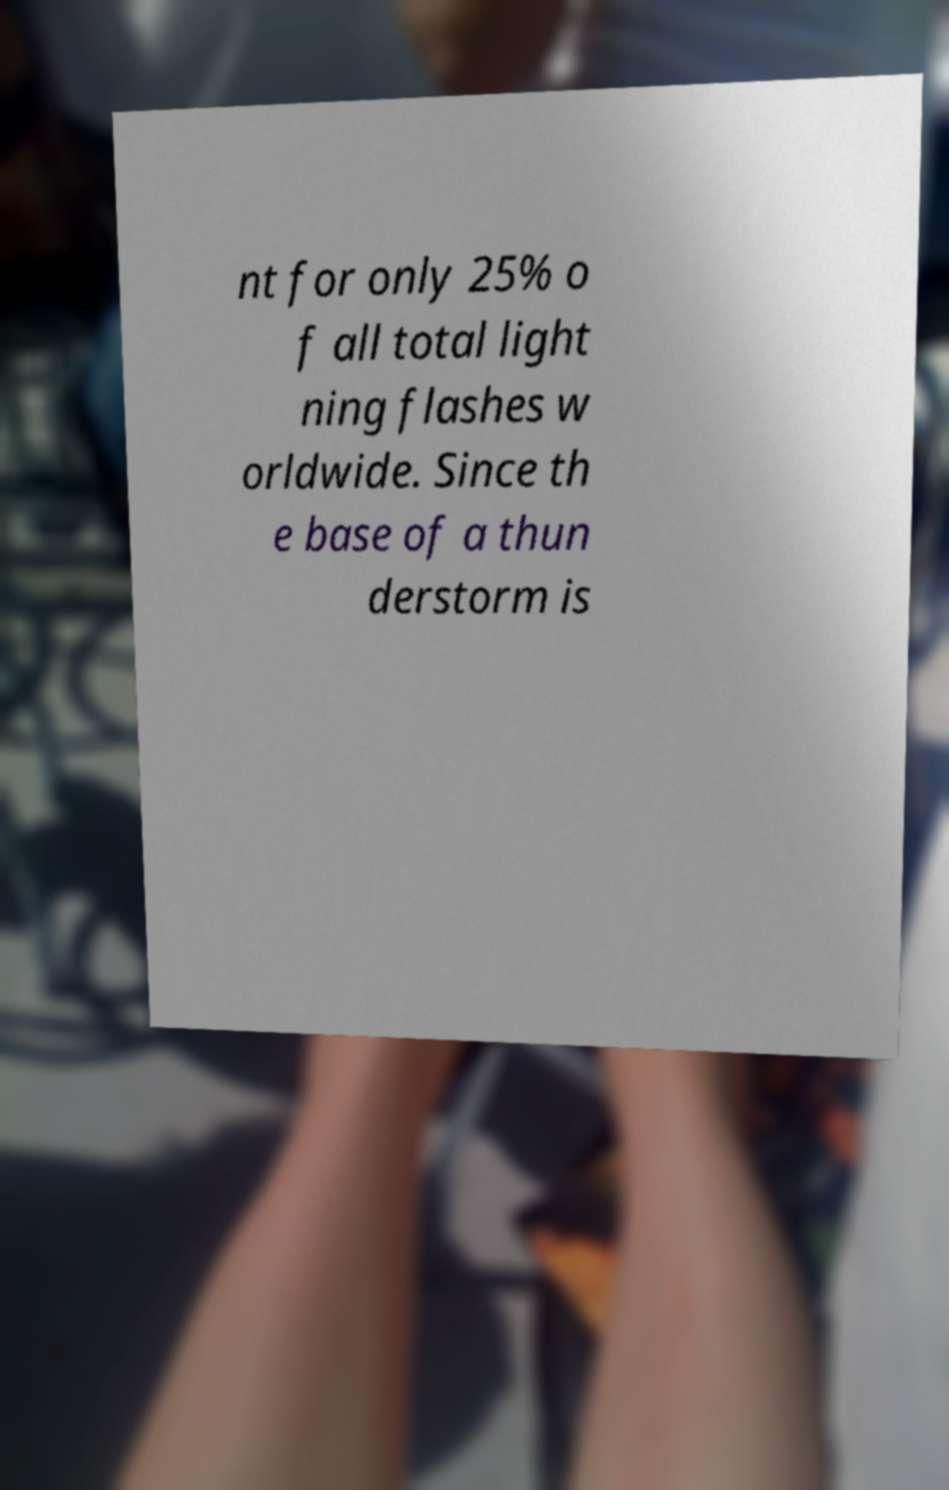For documentation purposes, I need the text within this image transcribed. Could you provide that? nt for only 25% o f all total light ning flashes w orldwide. Since th e base of a thun derstorm is 